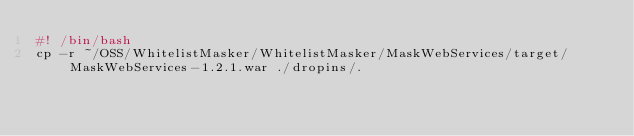Convert code to text. <code><loc_0><loc_0><loc_500><loc_500><_Bash_>#! /bin/bash
cp -r ~/OSS/WhitelistMasker/WhitelistMasker/MaskWebServices/target/MaskWebServices-1.2.1.war ./dropins/.
</code> 